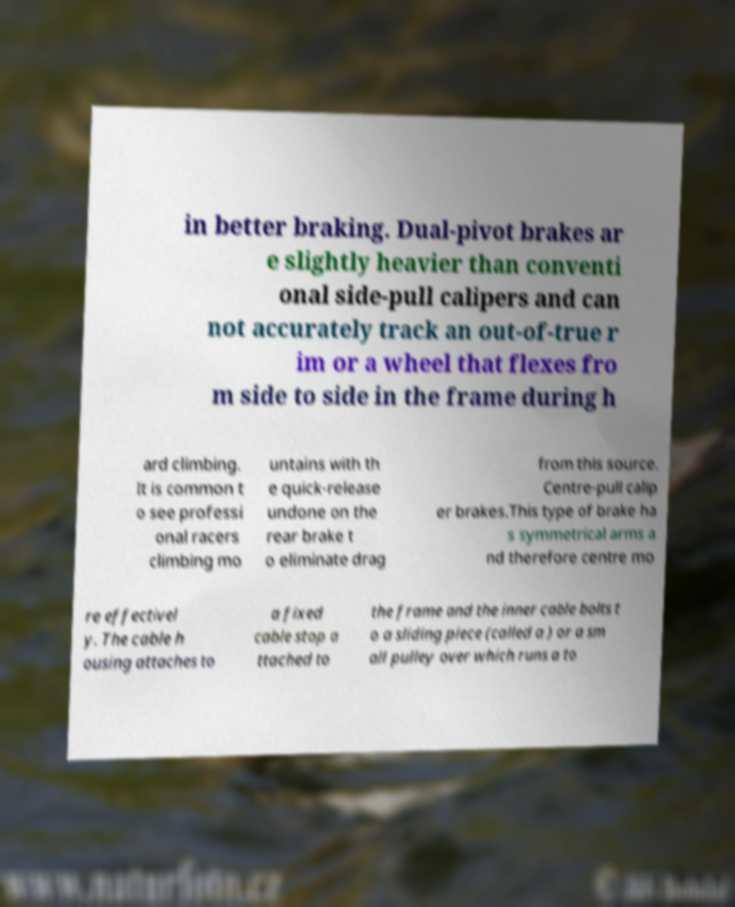Please read and relay the text visible in this image. What does it say? in better braking. Dual-pivot brakes ar e slightly heavier than conventi onal side-pull calipers and can not accurately track an out-of-true r im or a wheel that flexes fro m side to side in the frame during h ard climbing. It is common t o see professi onal racers climbing mo untains with th e quick-release undone on the rear brake t o eliminate drag from this source. Centre-pull calip er brakes.This type of brake ha s symmetrical arms a nd therefore centre mo re effectivel y. The cable h ousing attaches to a fixed cable stop a ttached to the frame and the inner cable bolts t o a sliding piece (called a ) or a sm all pulley over which runs a to 